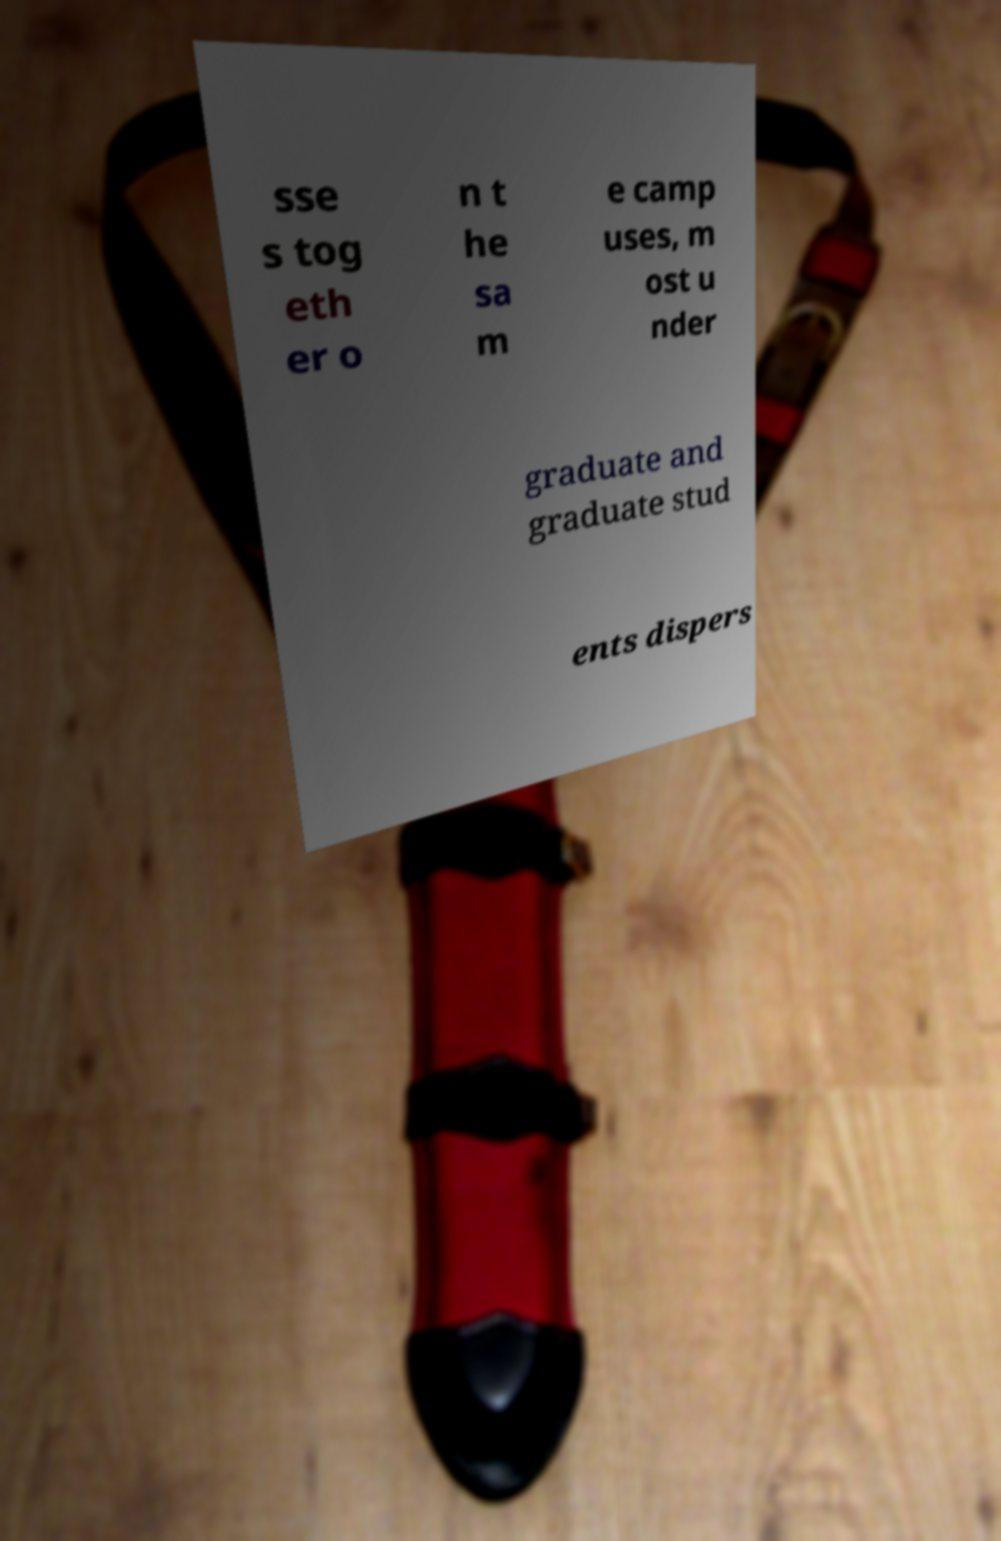Can you accurately transcribe the text from the provided image for me? sse s tog eth er o n t he sa m e camp uses, m ost u nder graduate and graduate stud ents dispers 